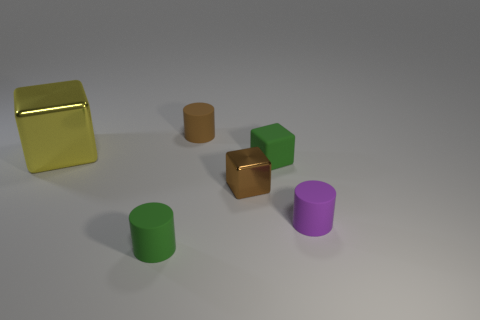What is the size of the other thing that is the same color as the tiny shiny thing?
Offer a terse response. Small. There is a object in front of the purple rubber cylinder; what number of tiny green matte cubes are in front of it?
Offer a very short reply. 0. What number of objects are small matte objects that are in front of the matte block or large yellow things?
Provide a succinct answer. 3. What number of other cylinders are the same material as the small brown cylinder?
Offer a very short reply. 2. The small matte thing that is the same color as the tiny shiny thing is what shape?
Keep it short and to the point. Cylinder. Is the number of small green cylinders that are in front of the yellow metallic block the same as the number of green matte cylinders?
Provide a succinct answer. Yes. There is a object behind the big yellow block; what size is it?
Offer a terse response. Small. What number of big things are either objects or brown matte things?
Your answer should be compact. 1. There is a tiny matte thing that is the same shape as the yellow metallic object; what is its color?
Make the answer very short. Green. Does the rubber cube have the same size as the brown metallic object?
Your response must be concise. Yes. 